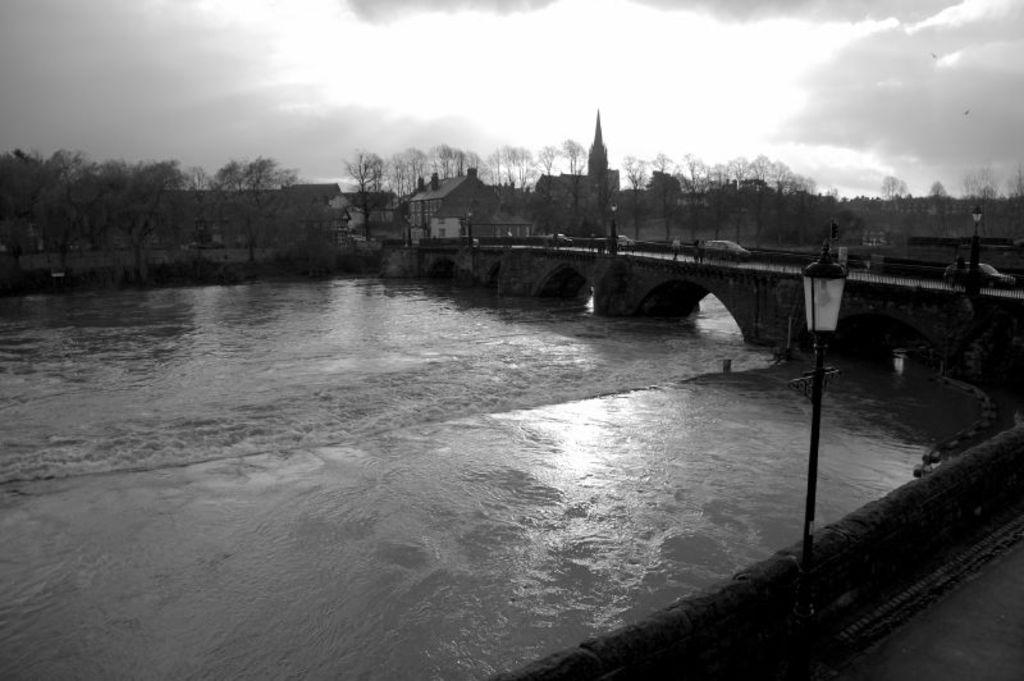What is happening on the bridge in the image? There are vehicles on a bridge in the image. What can be seen on the bridge besides the vehicles? There are poles on the bridge in the image. What is visible below the bridge? There is water visible in the image. What type of surface can be seen in the image? There is a road in the image. What structures are present in the image? There is a wall and buildings in the image. What type of vegetation is visible in the image? There are trees in the image. What is visible in the background of the image? The sky is visible in the background of the image, and there are clouds in the sky. What type of coach can be seen training the beast in the image? There is no coach or beast present in the image. How many nails are visible on the bridge in the image? There is no mention of nails in the image; the focus is on vehicles, poles, water, road, wall, buildings, trees, and the sky. 